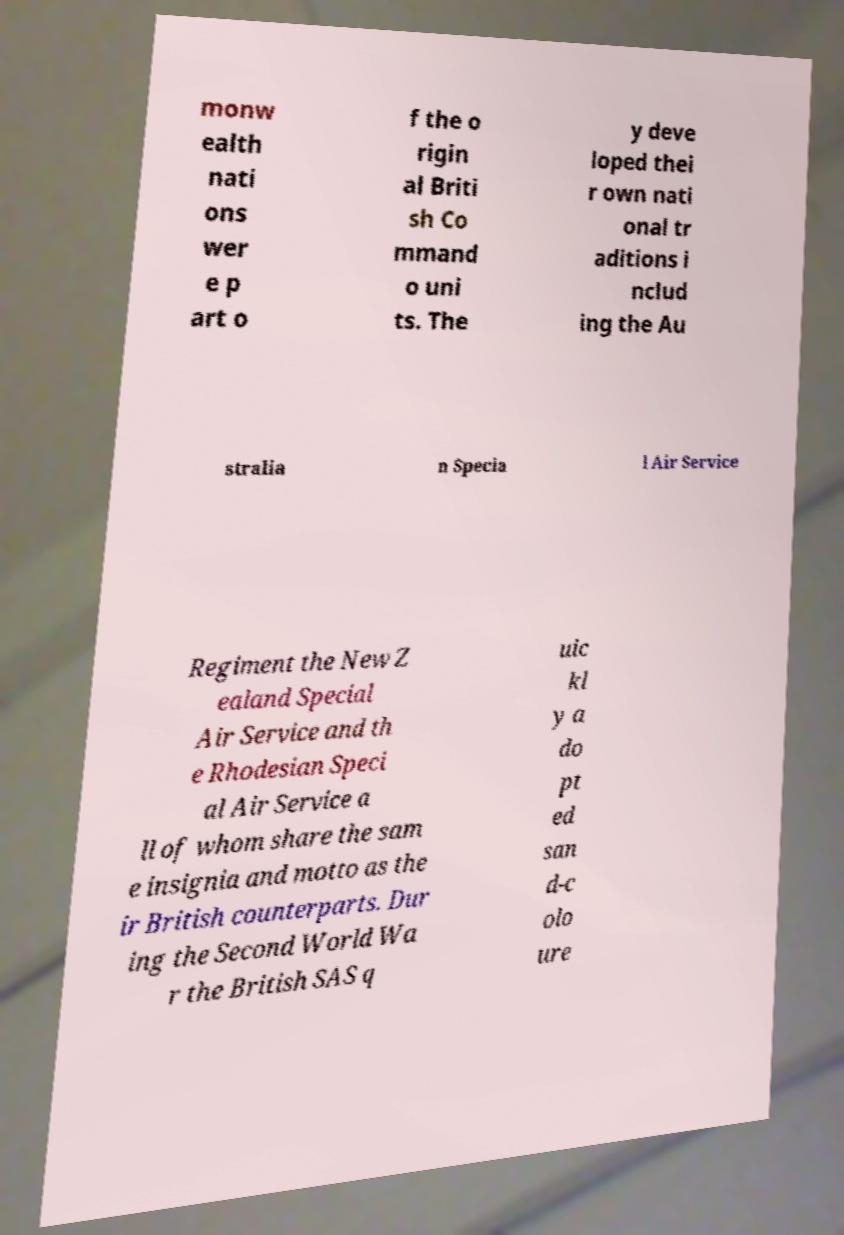For documentation purposes, I need the text within this image transcribed. Could you provide that? monw ealth nati ons wer e p art o f the o rigin al Briti sh Co mmand o uni ts. The y deve loped thei r own nati onal tr aditions i nclud ing the Au stralia n Specia l Air Service Regiment the New Z ealand Special Air Service and th e Rhodesian Speci al Air Service a ll of whom share the sam e insignia and motto as the ir British counterparts. Dur ing the Second World Wa r the British SAS q uic kl y a do pt ed san d-c olo ure 